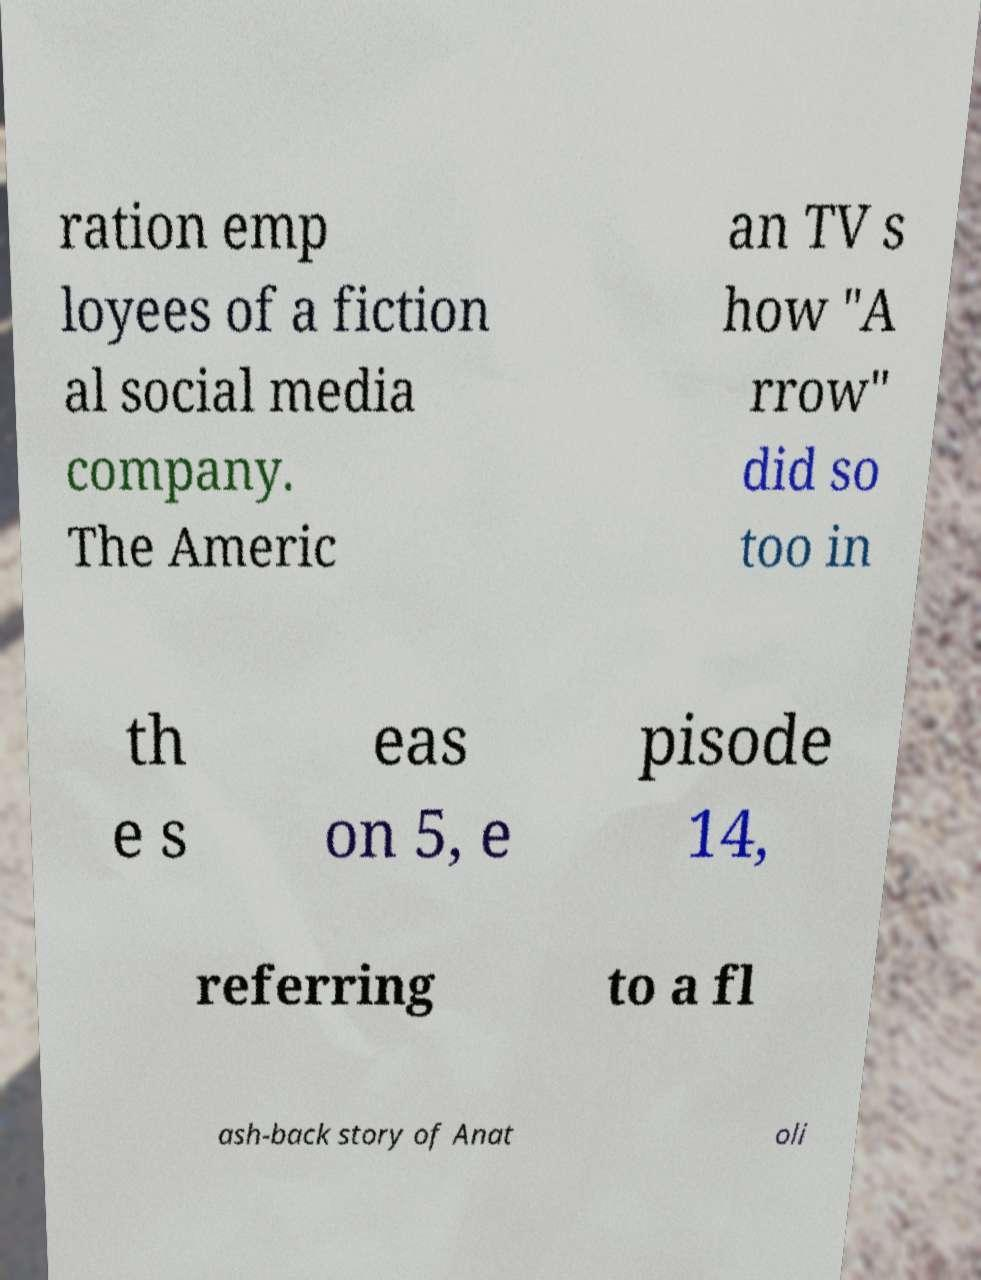There's text embedded in this image that I need extracted. Can you transcribe it verbatim? ration emp loyees of a fiction al social media company. The Americ an TV s how "A rrow" did so too in th e s eas on 5, e pisode 14, referring to a fl ash-back story of Anat oli 